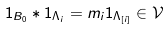<formula> <loc_0><loc_0><loc_500><loc_500>1 _ { B _ { 0 } } * 1 _ { \Lambda _ { i } } = m _ { i } 1 _ { \Lambda _ { [ i ] } } \in \mathcal { V }</formula> 